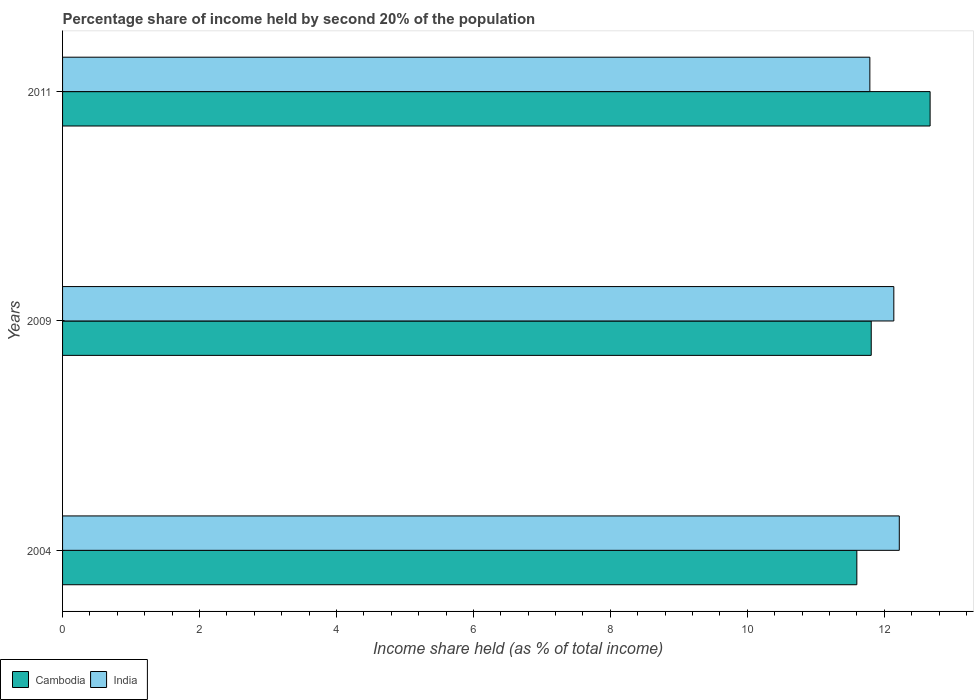How many bars are there on the 3rd tick from the top?
Keep it short and to the point. 2. How many bars are there on the 3rd tick from the bottom?
Provide a short and direct response. 2. What is the label of the 2nd group of bars from the top?
Provide a short and direct response. 2009. In how many cases, is the number of bars for a given year not equal to the number of legend labels?
Provide a short and direct response. 0. What is the share of income held by second 20% of the population in Cambodia in 2011?
Make the answer very short. 12.67. Across all years, what is the maximum share of income held by second 20% of the population in Cambodia?
Offer a very short reply. 12.67. Across all years, what is the minimum share of income held by second 20% of the population in India?
Make the answer very short. 11.79. In which year was the share of income held by second 20% of the population in India maximum?
Give a very brief answer. 2004. In which year was the share of income held by second 20% of the population in Cambodia minimum?
Keep it short and to the point. 2004. What is the total share of income held by second 20% of the population in Cambodia in the graph?
Your answer should be compact. 36.08. What is the difference between the share of income held by second 20% of the population in India in 2004 and that in 2011?
Your answer should be compact. 0.43. What is the difference between the share of income held by second 20% of the population in India in 2004 and the share of income held by second 20% of the population in Cambodia in 2011?
Your response must be concise. -0.45. What is the average share of income held by second 20% of the population in India per year?
Offer a terse response. 12.05. In the year 2009, what is the difference between the share of income held by second 20% of the population in India and share of income held by second 20% of the population in Cambodia?
Ensure brevity in your answer.  0.33. What is the ratio of the share of income held by second 20% of the population in India in 2004 to that in 2009?
Offer a very short reply. 1.01. Is the share of income held by second 20% of the population in Cambodia in 2004 less than that in 2011?
Your answer should be compact. Yes. What is the difference between the highest and the second highest share of income held by second 20% of the population in India?
Provide a short and direct response. 0.08. What is the difference between the highest and the lowest share of income held by second 20% of the population in Cambodia?
Provide a short and direct response. 1.07. What does the 2nd bar from the top in 2009 represents?
Your answer should be compact. Cambodia. What does the 1st bar from the bottom in 2004 represents?
Offer a very short reply. Cambodia. Are all the bars in the graph horizontal?
Ensure brevity in your answer.  Yes. How many years are there in the graph?
Keep it short and to the point. 3. Where does the legend appear in the graph?
Give a very brief answer. Bottom left. How many legend labels are there?
Give a very brief answer. 2. What is the title of the graph?
Your answer should be very brief. Percentage share of income held by second 20% of the population. Does "Haiti" appear as one of the legend labels in the graph?
Your answer should be compact. No. What is the label or title of the X-axis?
Give a very brief answer. Income share held (as % of total income). What is the Income share held (as % of total income) of Cambodia in 2004?
Your response must be concise. 11.6. What is the Income share held (as % of total income) in India in 2004?
Your answer should be very brief. 12.22. What is the Income share held (as % of total income) in Cambodia in 2009?
Keep it short and to the point. 11.81. What is the Income share held (as % of total income) of India in 2009?
Make the answer very short. 12.14. What is the Income share held (as % of total income) of Cambodia in 2011?
Your answer should be very brief. 12.67. What is the Income share held (as % of total income) of India in 2011?
Make the answer very short. 11.79. Across all years, what is the maximum Income share held (as % of total income) in Cambodia?
Give a very brief answer. 12.67. Across all years, what is the maximum Income share held (as % of total income) of India?
Your answer should be very brief. 12.22. Across all years, what is the minimum Income share held (as % of total income) in Cambodia?
Your answer should be very brief. 11.6. Across all years, what is the minimum Income share held (as % of total income) of India?
Keep it short and to the point. 11.79. What is the total Income share held (as % of total income) in Cambodia in the graph?
Your answer should be very brief. 36.08. What is the total Income share held (as % of total income) in India in the graph?
Offer a terse response. 36.15. What is the difference between the Income share held (as % of total income) of Cambodia in 2004 and that in 2009?
Your answer should be compact. -0.21. What is the difference between the Income share held (as % of total income) in India in 2004 and that in 2009?
Your response must be concise. 0.08. What is the difference between the Income share held (as % of total income) of Cambodia in 2004 and that in 2011?
Give a very brief answer. -1.07. What is the difference between the Income share held (as % of total income) in India in 2004 and that in 2011?
Make the answer very short. 0.43. What is the difference between the Income share held (as % of total income) in Cambodia in 2009 and that in 2011?
Offer a terse response. -0.86. What is the difference between the Income share held (as % of total income) in Cambodia in 2004 and the Income share held (as % of total income) in India in 2009?
Offer a terse response. -0.54. What is the difference between the Income share held (as % of total income) in Cambodia in 2004 and the Income share held (as % of total income) in India in 2011?
Provide a short and direct response. -0.19. What is the average Income share held (as % of total income) of Cambodia per year?
Make the answer very short. 12.03. What is the average Income share held (as % of total income) in India per year?
Provide a short and direct response. 12.05. In the year 2004, what is the difference between the Income share held (as % of total income) in Cambodia and Income share held (as % of total income) in India?
Your answer should be compact. -0.62. In the year 2009, what is the difference between the Income share held (as % of total income) of Cambodia and Income share held (as % of total income) of India?
Ensure brevity in your answer.  -0.33. What is the ratio of the Income share held (as % of total income) in Cambodia in 2004 to that in 2009?
Make the answer very short. 0.98. What is the ratio of the Income share held (as % of total income) of India in 2004 to that in 2009?
Your response must be concise. 1.01. What is the ratio of the Income share held (as % of total income) in Cambodia in 2004 to that in 2011?
Offer a very short reply. 0.92. What is the ratio of the Income share held (as % of total income) of India in 2004 to that in 2011?
Your answer should be very brief. 1.04. What is the ratio of the Income share held (as % of total income) of Cambodia in 2009 to that in 2011?
Give a very brief answer. 0.93. What is the ratio of the Income share held (as % of total income) of India in 2009 to that in 2011?
Offer a very short reply. 1.03. What is the difference between the highest and the second highest Income share held (as % of total income) in Cambodia?
Your response must be concise. 0.86. What is the difference between the highest and the second highest Income share held (as % of total income) of India?
Give a very brief answer. 0.08. What is the difference between the highest and the lowest Income share held (as % of total income) in Cambodia?
Keep it short and to the point. 1.07. What is the difference between the highest and the lowest Income share held (as % of total income) in India?
Ensure brevity in your answer.  0.43. 